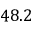<formula> <loc_0><loc_0><loc_500><loc_500>4 8 . 2</formula> 